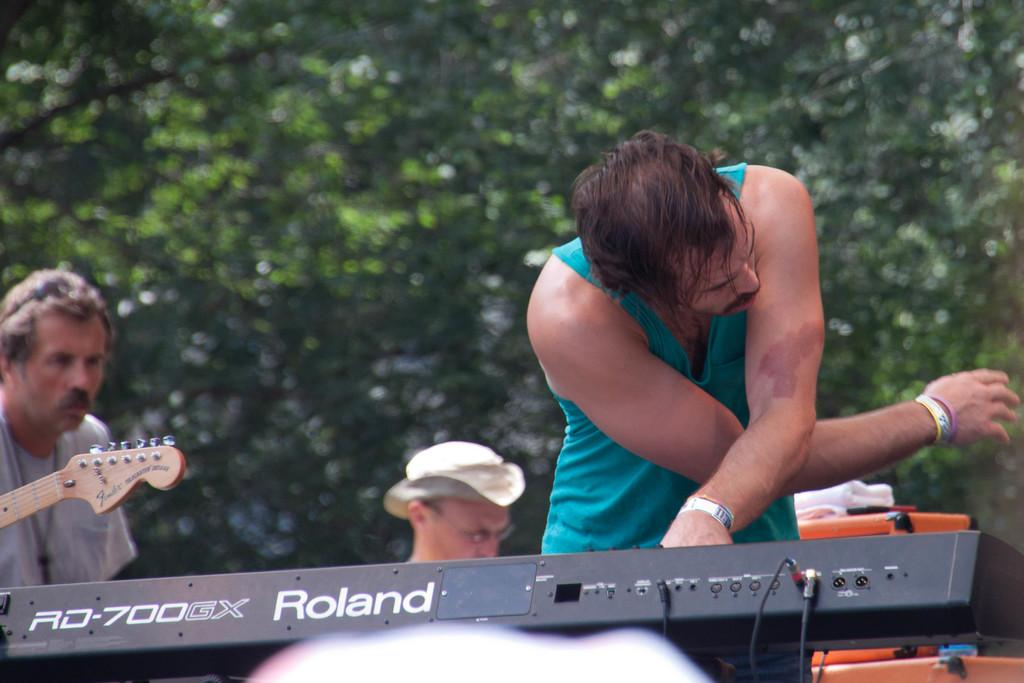What are the people in the image doing? The people in the image are playing musical instruments. What can be seen behind the people in the image? There are trees behind the people in the image. Can you see a cave behind the people in the image? No, there is no cave visible in the image; only trees can be seen behind the people. 